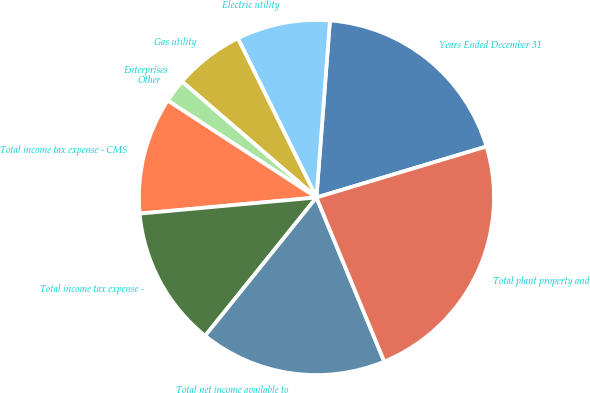Convert chart. <chart><loc_0><loc_0><loc_500><loc_500><pie_chart><fcel>Years Ended December 31<fcel>Electric utility<fcel>Gas utility<fcel>Enterprises<fcel>Other<fcel>Total income tax expense - CMS<fcel>Total income tax expense -<fcel>Total net income available to<fcel>Total plant property and<nl><fcel>19.15%<fcel>8.51%<fcel>6.38%<fcel>0.0%<fcel>2.13%<fcel>10.64%<fcel>12.77%<fcel>17.02%<fcel>23.4%<nl></chart> 